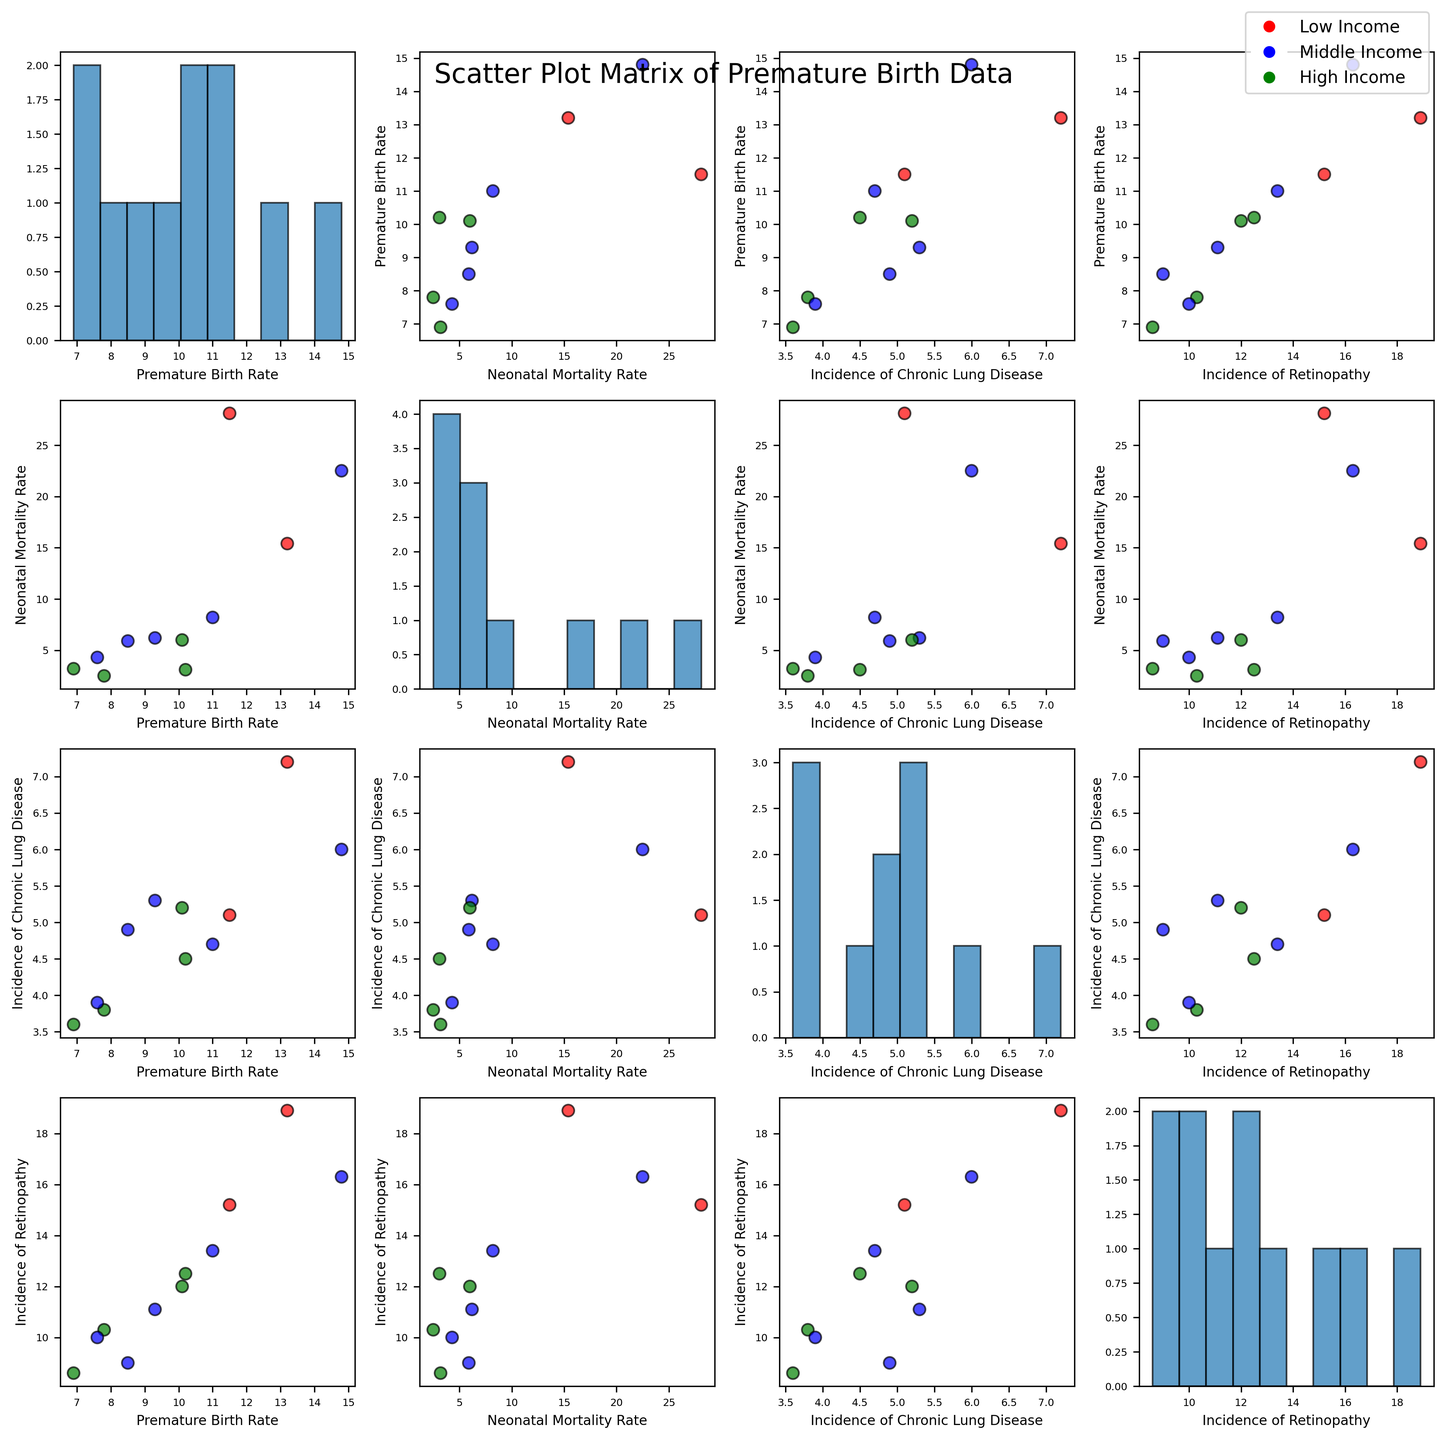What is the title of the figure? The title of the figure is the text located at the top center. By referring to this part, we can read the title directly.
Answer: "Scatter Plot Matrix of Premature Birth Data" Which income category is colored in red? By observing the scatter plot matrix, we see that red corresponds to the "Low" income category. This is determined by the legend included in the figure.
Answer: Low Income How many bins are used in the histogram for "Neonatal Mortality Rate"? By looking at the histograms on the diagonal part of the matrix, we can count the number of bins (rectangles). The histogram for Neonatal Mortality Rate shows 10 bins.
Answer: 10 Which region has the highest incidence of Chronic Lung Disease? By examining the scatter plots and looking at "Incidence of Chronic Lung Disease" values on the y-axis, Africa with Low income has the highest at 7.2.
Answer: Africa (Low) Compare the Premature Birth Rate for North America in high and middle income categories. Which is higher? From the scatter plot labeled for Premature Birth Rate vs. Neonatal Mortality Rate, we identify North America's high-income (green) and middle-income (blue) points. The Premature Birth Rate is higher for middle-income at 11.0 compared to high-income at 10.2.
Answer: North America (Middle) What is the average Neonatal Mortality Rate across all high-income regions? To calculate the average, add high-income Neonatal Mortality Rates: 3.1 (North America) + 2.5 (Europe) + 3.2 (Oceania) + 6.0 (Asia). The sum is 14.8, and there are 4 data points. Divide the sum by 4.
Answer: 3.7 Is the Neonatal Mortality Rate positively correlated with Incidence of Retinopathy? By observing the scatter plots, particularly "Neonatal Mortality Rate" vs. "Incidence of Retinopathy," we note that as Neonatal Mortality Rate increases, "Incidence of Retinopathy" does as well. This suggests a positive correlation.
Answer: Yes What relationship can be observed between Premature Birth Rate and Incidence of Retinopathy for middle-income categories? In the scatter plot labeled "Premature Birth Rate" vs. "Incidence of Retinopathy," we look at the blue points representing middle-income. There seems to be a trend where higher Premature Birth Rates appear alongside higher Incidence of Retinopathy.
Answer: Higher Premature Birth Rates associate with higher Incidence of Retinopathy 